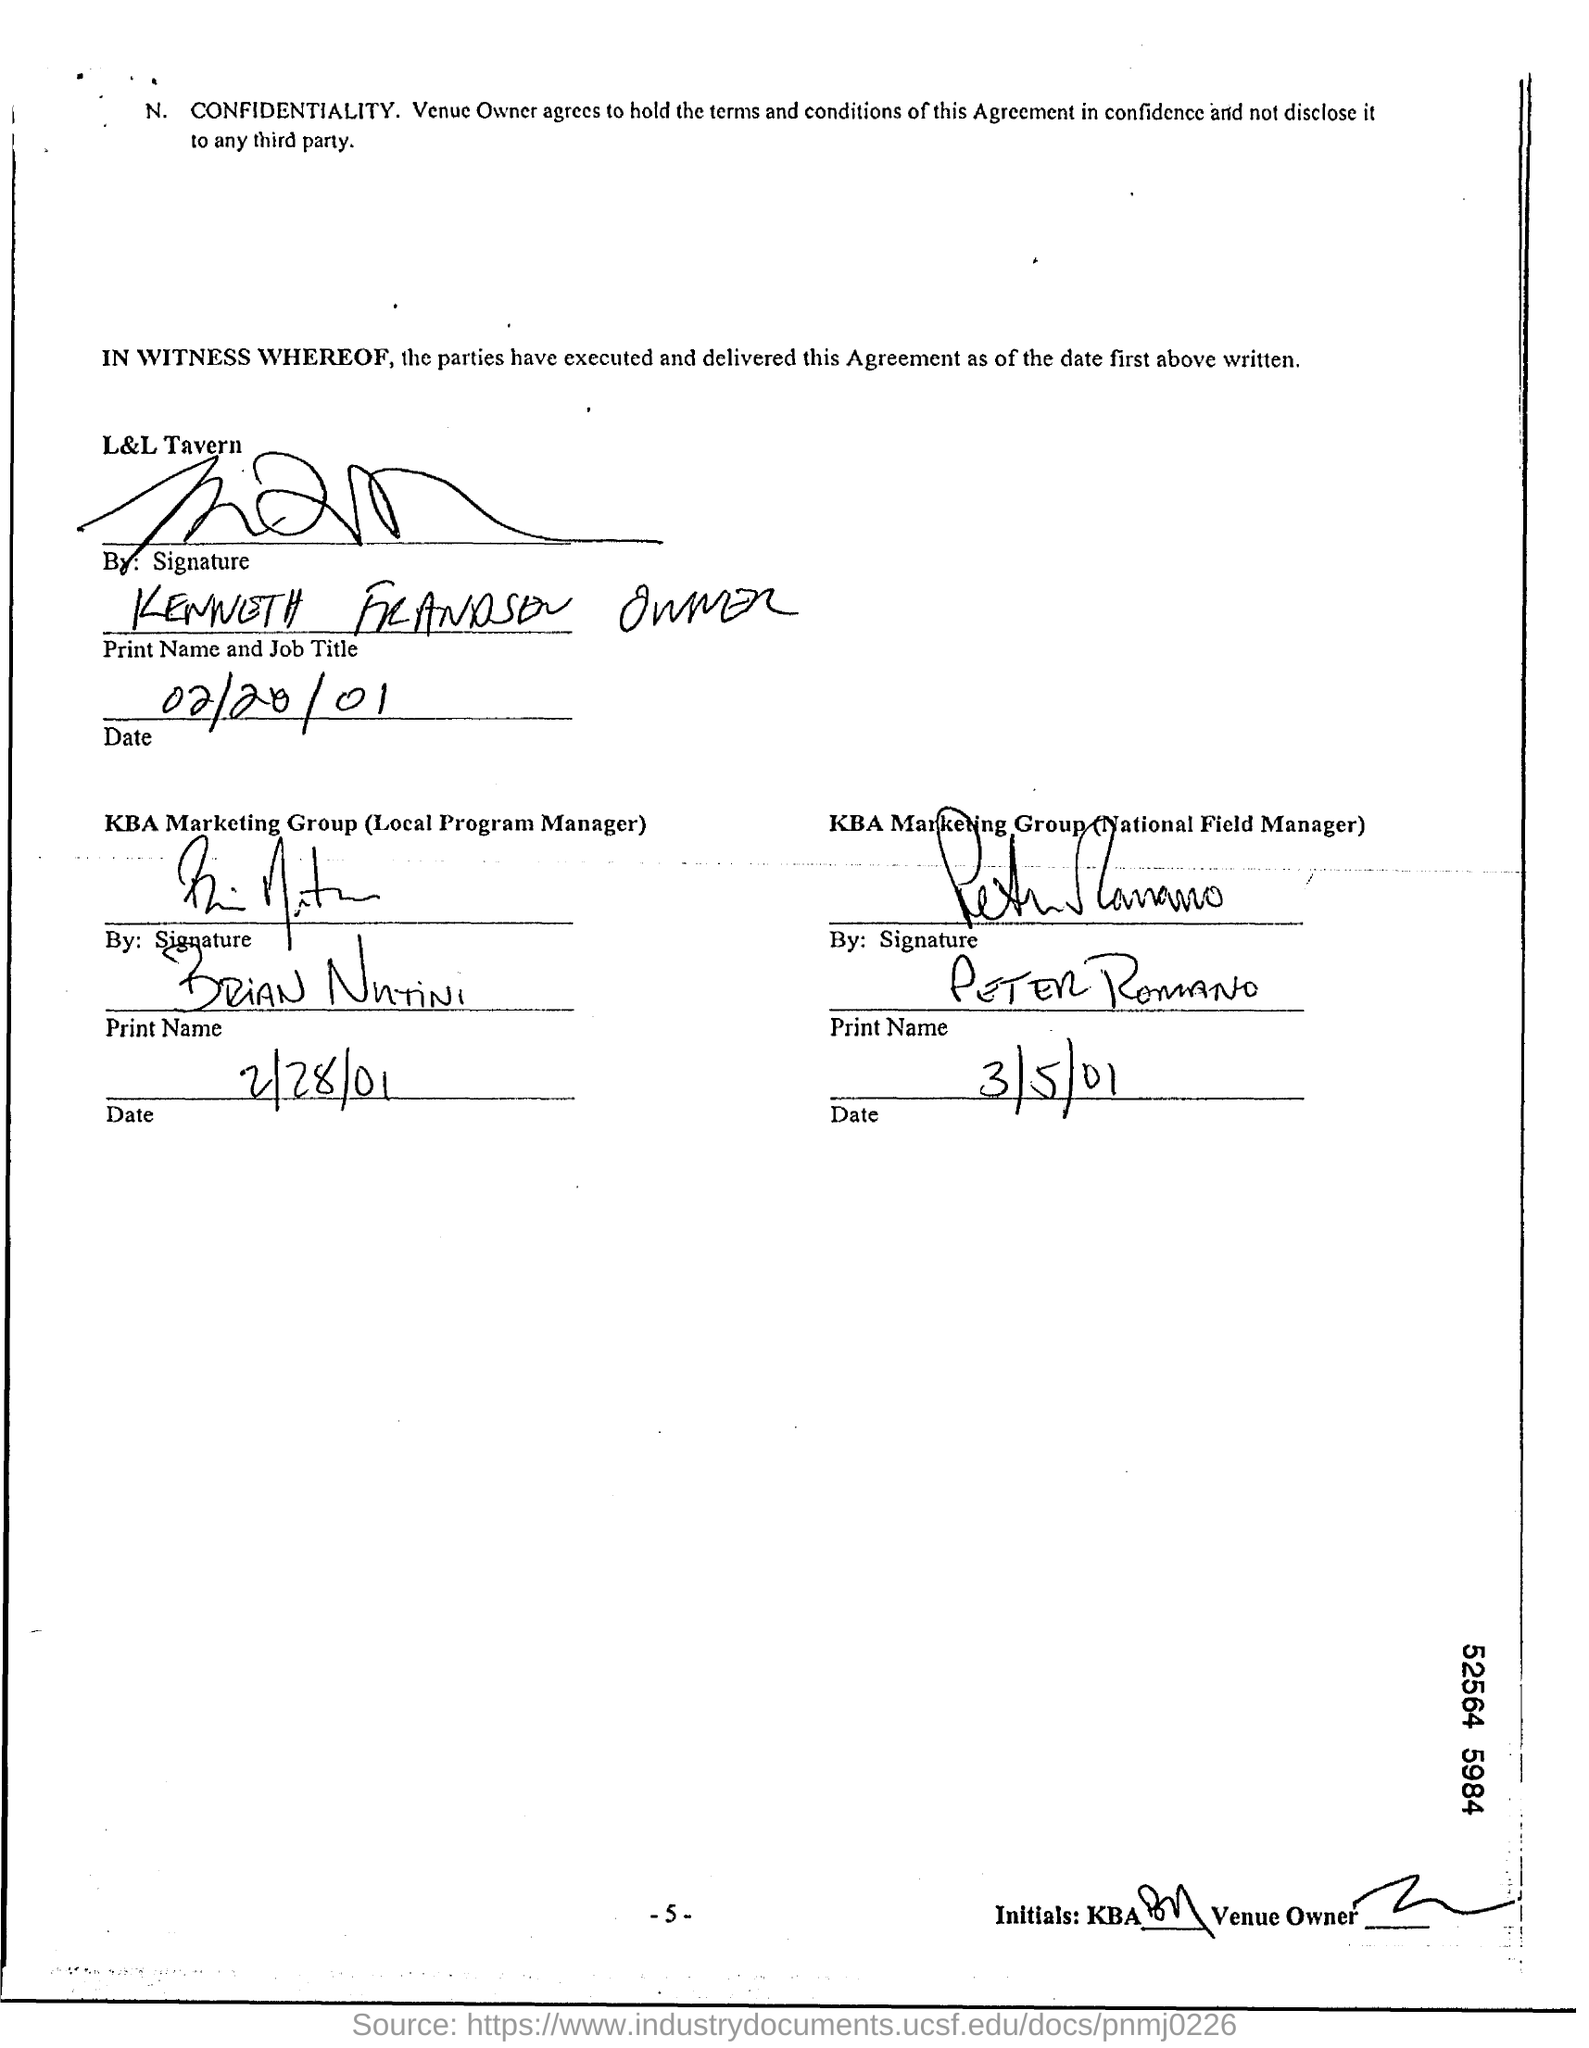What is the date written for L&L Tavern? The date written for L&L Tavern is February 20th, 2001, as indicated by the notation '02/20/01' next to the signature of the owner. 